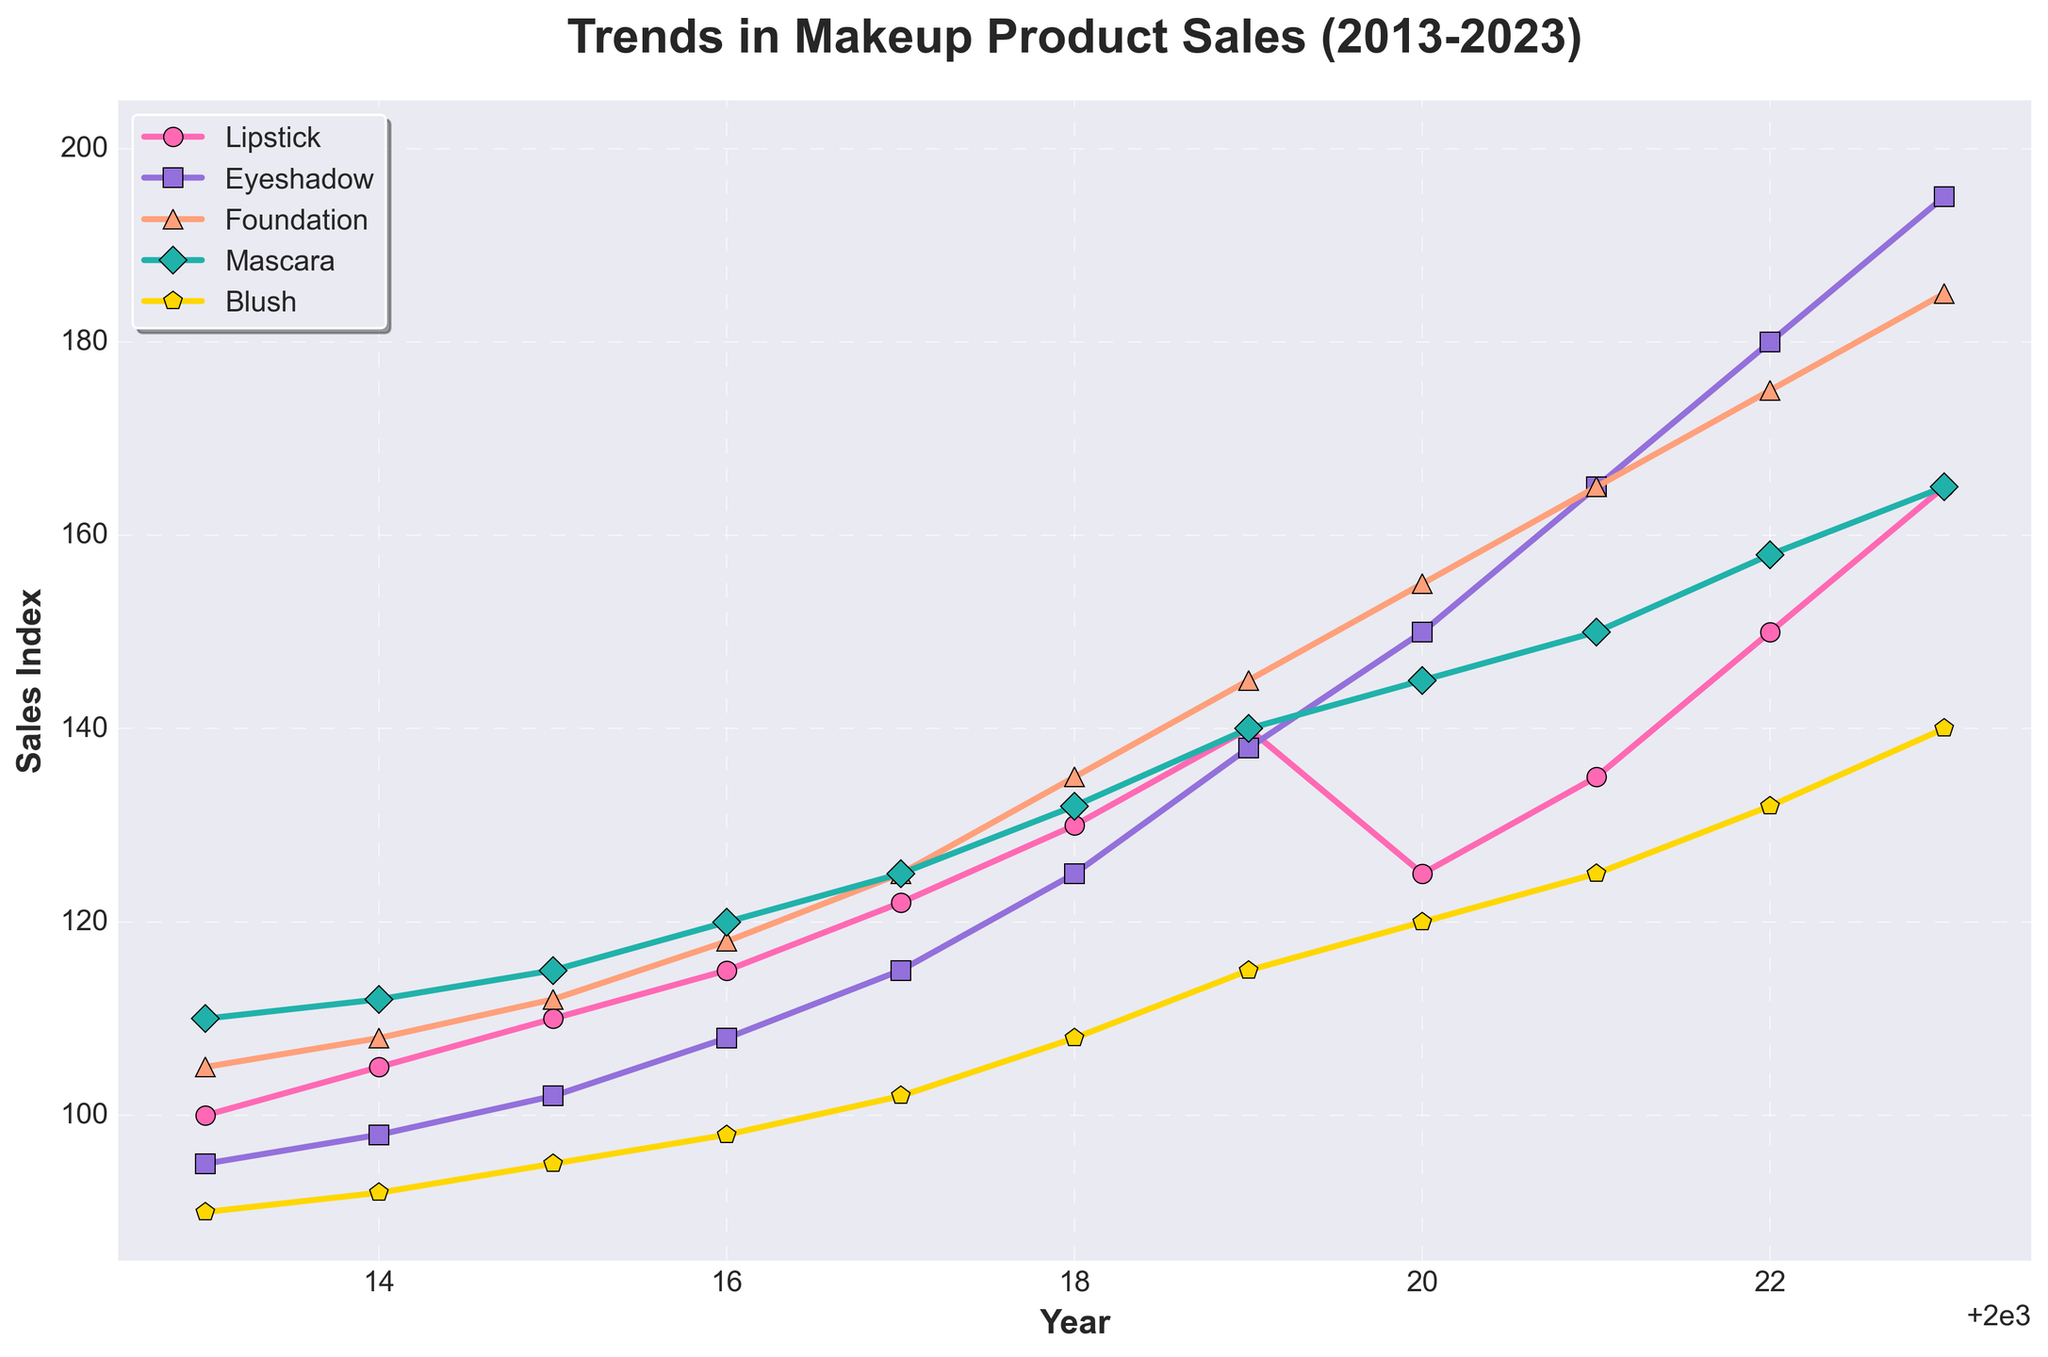What year did Lipstick sales surpass 150 in the Sales Index? The line representing Lipstick sales crosses the 150 mark in the Sales Index at the year 2022.
Answer: 2022 Compare the sales of Eyeshadow and Mascara in 2018. Which one is higher and by how much? In 2018, Eyeshadow has a Sales Index of 125 while Mascara has 132. The difference is 132 - 125 = 7.
Answer: Mascara, by 7 Which product type had the most significant increase in sales from 2013 to 2023? To determine the most significant increase, we calculate the difference between 2023 and 2013 for each product: Lipstick (165-100 = 65), Eyeshadow (195-95 = 100), Foundation (185-105 = 80), Mascara (165-110 = 55), Blush (140-90 = 50). Eyeshadow has the largest increase.
Answer: Eyeshadow In what year did Foundation sales first reach 150 in the Sales Index? The line representing Foundation sales first reaches the 150 mark in the Sales Index in the year 2019.
Answer: 2019 By how much did Blush sales increase from 2013 to 2020? Blush sales in 2020 are 120 and in 2013 are 90. The increase is 120 - 90 = 30.
Answer: 30 Which product had the smallest Sales Index in 2013, and what was the value? In 2013, Blush had the smallest Sales Index value of 90 among all the products.
Answer: Blush, 90 What is the average Sales Index of Mascara over the decade (2013-2023)? The Sales Index values for Mascara from 2013 to 2023 are: 110, 112, 115, 120, 125, 132, 140, 145, 150, 158, 165. The sum is 1372 and there are 11 years, so the average is 1372 / 11 ≈ 124.73.
Answer: 124.73 Compare the sales trends of Lipstick and Foundation over the decade and identify which one had a more consistent upward trend. To determine the consistency in the upward trend, we observe that both Lipstick and Foundation generally increase each year. However, Lipstick decreases slightly only in 2020 while Foundation decreases never decreases, suggesting Foundation has a more consistent upward trend.
Answer: Foundation What is the difference between the highest and lowest Sales Index values recorded for Eyeshadow over the decade? The highest Sales Index for Eyeshadow is 195 (2023) and the lowest is 95 (2013). The difference is 195 - 95 = 100.
Answer: 100 Identify the year when Blush sales grew the most sharply compared to the previous year. What is the increase? Blush sales increased the most from 2021 to 2022, where it increased from 125 to 132. The increase is 132 - 125 = 7.
Answer: 2022, 7 